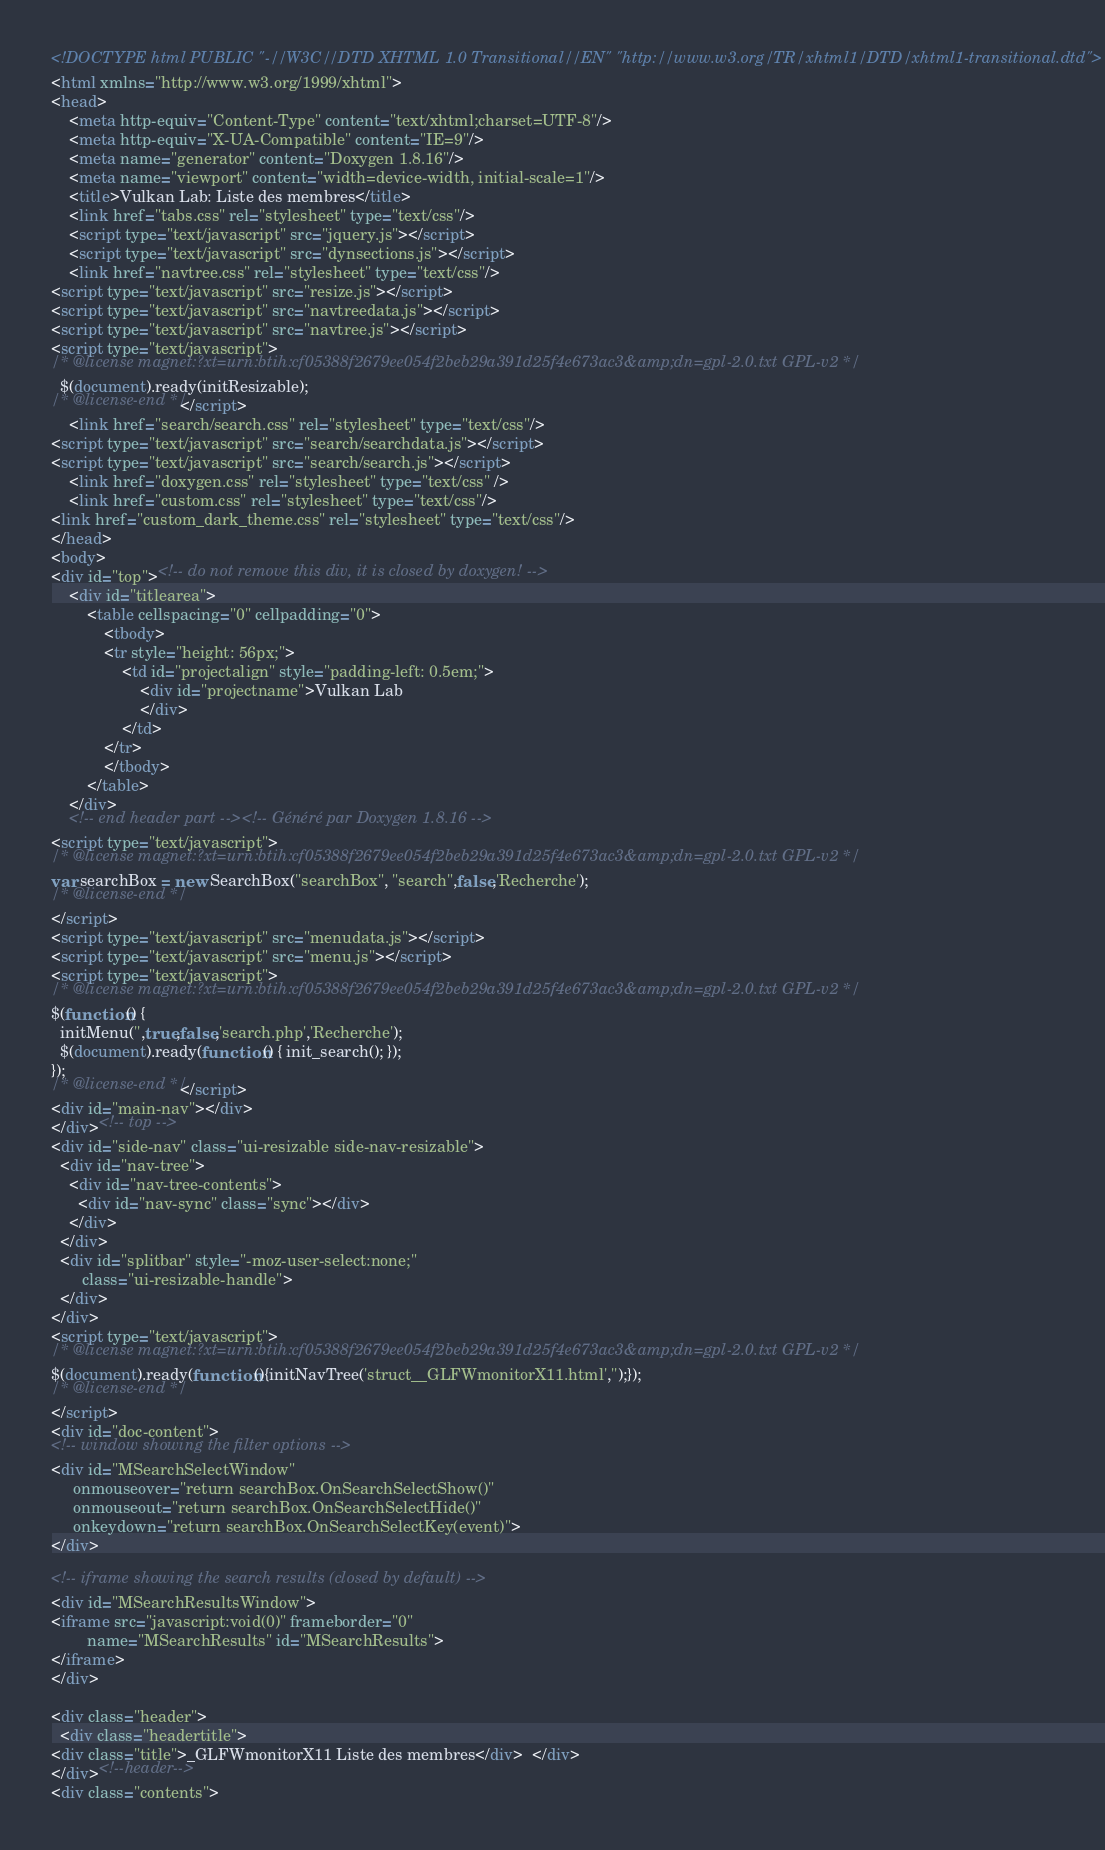<code> <loc_0><loc_0><loc_500><loc_500><_HTML_><!DOCTYPE html PUBLIC "-//W3C//DTD XHTML 1.0 Transitional//EN" "http://www.w3.org/TR/xhtml1/DTD/xhtml1-transitional.dtd">
<html xmlns="http://www.w3.org/1999/xhtml">
<head>
    <meta http-equiv="Content-Type" content="text/xhtml;charset=UTF-8"/>
    <meta http-equiv="X-UA-Compatible" content="IE=9"/>
    <meta name="generator" content="Doxygen 1.8.16"/>
    <meta name="viewport" content="width=device-width, initial-scale=1"/>
    <title>Vulkan Lab: Liste des membres</title>
    <link href="tabs.css" rel="stylesheet" type="text/css"/>
    <script type="text/javascript" src="jquery.js"></script>
    <script type="text/javascript" src="dynsections.js"></script>
    <link href="navtree.css" rel="stylesheet" type="text/css"/>
<script type="text/javascript" src="resize.js"></script>
<script type="text/javascript" src="navtreedata.js"></script>
<script type="text/javascript" src="navtree.js"></script>
<script type="text/javascript">
/* @license magnet:?xt=urn:btih:cf05388f2679ee054f2beb29a391d25f4e673ac3&amp;dn=gpl-2.0.txt GPL-v2 */
  $(document).ready(initResizable);
/* @license-end */</script>
    <link href="search/search.css" rel="stylesheet" type="text/css"/>
<script type="text/javascript" src="search/searchdata.js"></script>
<script type="text/javascript" src="search/search.js"></script>
    <link href="doxygen.css" rel="stylesheet" type="text/css" />
    <link href="custom.css" rel="stylesheet" type="text/css"/>
<link href="custom_dark_theme.css" rel="stylesheet" type="text/css"/>
</head>
<body>
<div id="top"><!-- do not remove this div, it is closed by doxygen! -->
    <div id="titlearea">
        <table cellspacing="0" cellpadding="0">
            <tbody>
            <tr style="height: 56px;">
                <td id="projectalign" style="padding-left: 0.5em;">
                    <div id="projectname">Vulkan Lab
                    </div>
                </td>
            </tr>
            </tbody>
        </table>
    </div>
    <!-- end header part --><!-- Généré par Doxygen 1.8.16 -->
<script type="text/javascript">
/* @license magnet:?xt=urn:btih:cf05388f2679ee054f2beb29a391d25f4e673ac3&amp;dn=gpl-2.0.txt GPL-v2 */
var searchBox = new SearchBox("searchBox", "search",false,'Recherche');
/* @license-end */
</script>
<script type="text/javascript" src="menudata.js"></script>
<script type="text/javascript" src="menu.js"></script>
<script type="text/javascript">
/* @license magnet:?xt=urn:btih:cf05388f2679ee054f2beb29a391d25f4e673ac3&amp;dn=gpl-2.0.txt GPL-v2 */
$(function() {
  initMenu('',true,false,'search.php','Recherche');
  $(document).ready(function() { init_search(); });
});
/* @license-end */</script>
<div id="main-nav"></div>
</div><!-- top -->
<div id="side-nav" class="ui-resizable side-nav-resizable">
  <div id="nav-tree">
    <div id="nav-tree-contents">
      <div id="nav-sync" class="sync"></div>
    </div>
  </div>
  <div id="splitbar" style="-moz-user-select:none;" 
       class="ui-resizable-handle">
  </div>
</div>
<script type="text/javascript">
/* @license magnet:?xt=urn:btih:cf05388f2679ee054f2beb29a391d25f4e673ac3&amp;dn=gpl-2.0.txt GPL-v2 */
$(document).ready(function(){initNavTree('struct__GLFWmonitorX11.html','');});
/* @license-end */
</script>
<div id="doc-content">
<!-- window showing the filter options -->
<div id="MSearchSelectWindow"
     onmouseover="return searchBox.OnSearchSelectShow()"
     onmouseout="return searchBox.OnSearchSelectHide()"
     onkeydown="return searchBox.OnSearchSelectKey(event)">
</div>

<!-- iframe showing the search results (closed by default) -->
<div id="MSearchResultsWindow">
<iframe src="javascript:void(0)" frameborder="0" 
        name="MSearchResults" id="MSearchResults">
</iframe>
</div>

<div class="header">
  <div class="headertitle">
<div class="title">_GLFWmonitorX11 Liste des membres</div>  </div>
</div><!--header-->
<div class="contents">
</code> 